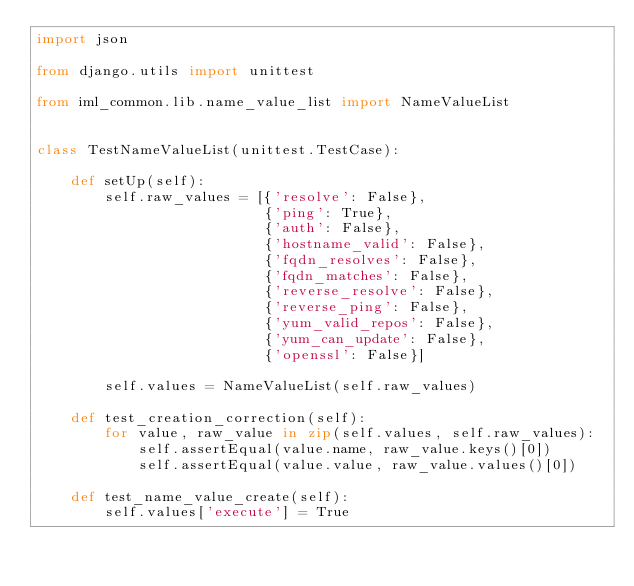<code> <loc_0><loc_0><loc_500><loc_500><_Python_>import json

from django.utils import unittest

from iml_common.lib.name_value_list import NameValueList


class TestNameValueList(unittest.TestCase):

    def setUp(self):
        self.raw_values = [{'resolve': False},
                           {'ping': True},
                           {'auth': False},
                           {'hostname_valid': False},
                           {'fqdn_resolves': False},
                           {'fqdn_matches': False},
                           {'reverse_resolve': False},
                           {'reverse_ping': False},
                           {'yum_valid_repos': False},
                           {'yum_can_update': False},
                           {'openssl': False}]

        self.values = NameValueList(self.raw_values)

    def test_creation_correction(self):
        for value, raw_value in zip(self.values, self.raw_values):
            self.assertEqual(value.name, raw_value.keys()[0])
            self.assertEqual(value.value, raw_value.values()[0])

    def test_name_value_create(self):
        self.values['execute'] = True</code> 